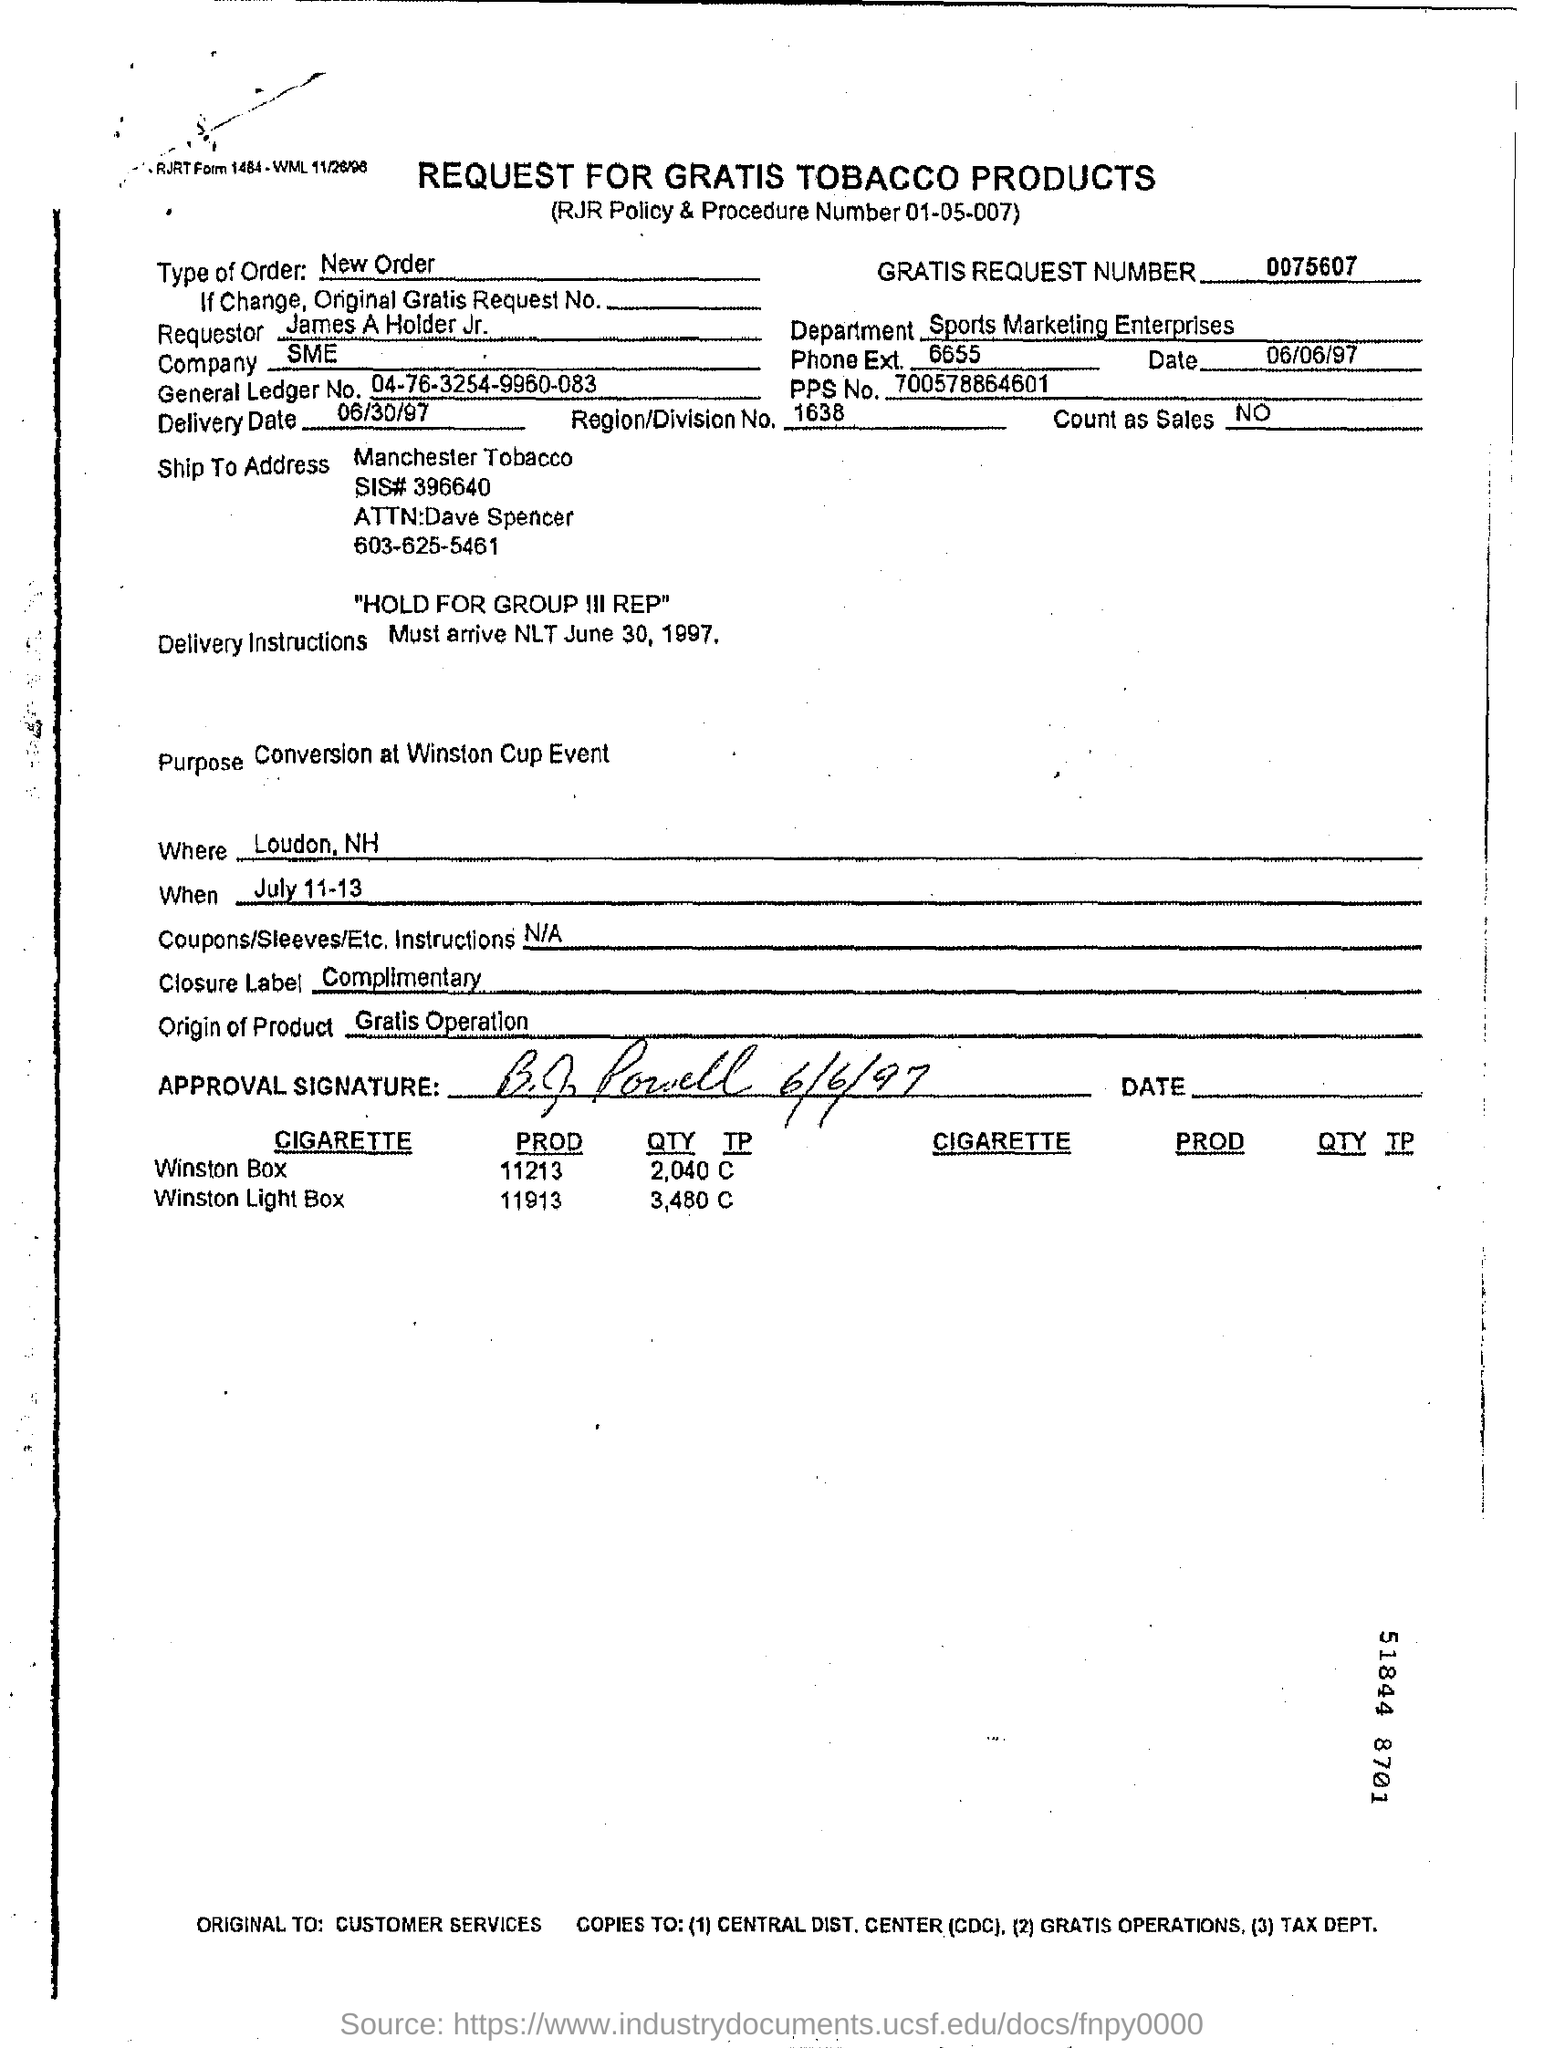Highlight a few significant elements in this photo. The general ledger number is "04-76-3254-9960-083. The region/division number is 1638. The Closure Label is a complimentary term that refers to the process of completing a task or achieving a goal. The Gratis Request Number is 0075607... The delivery date is June 30, 1997. 